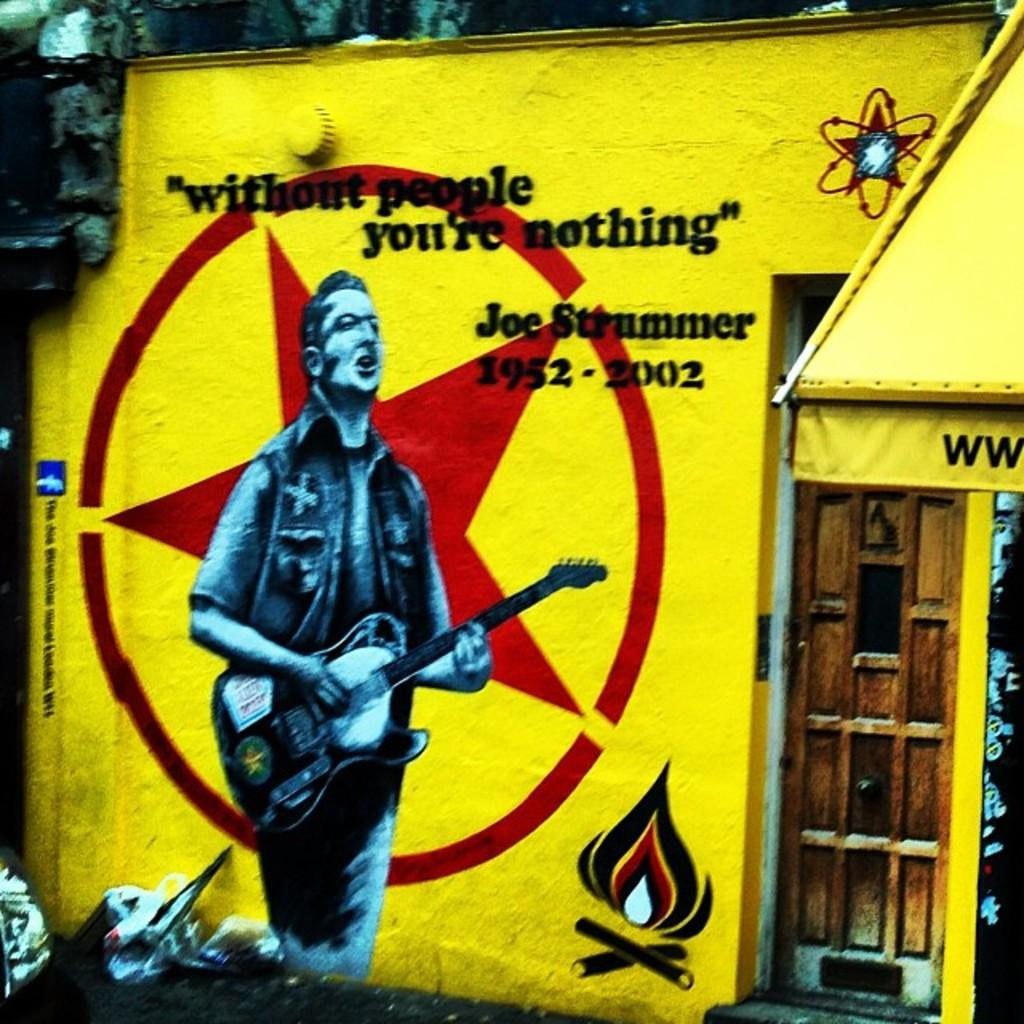<image>
Render a clear and concise summary of the photo. A quote from Joe Strummer on a painting on him. 